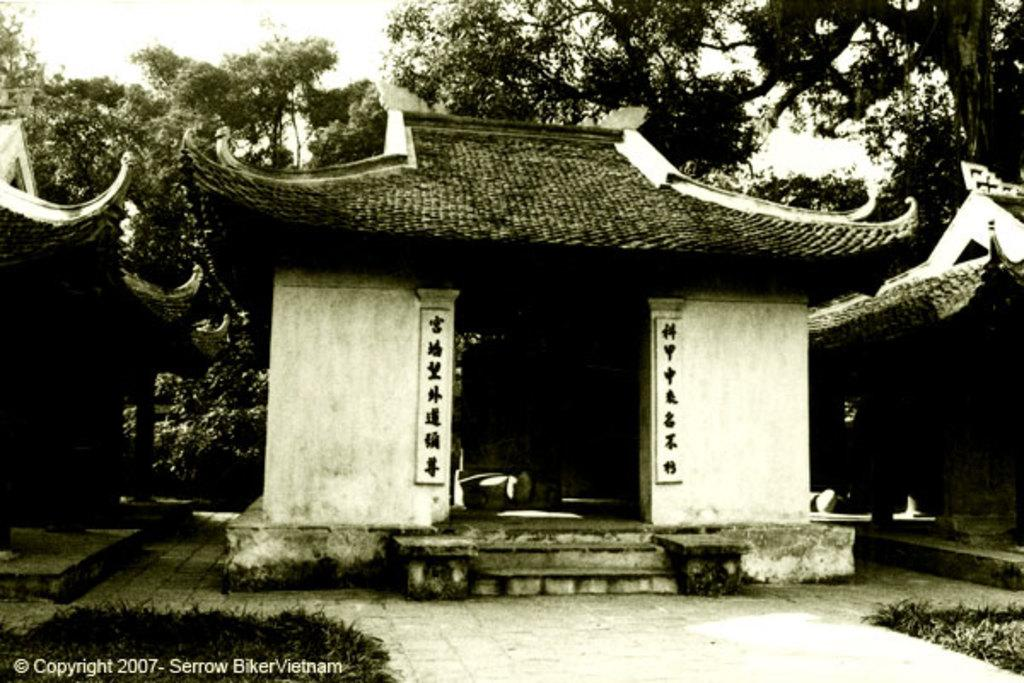What type of structures can be seen in the image? There are houses in the image. What type of vegetation is present in the image? There are trees and grass in the image. Can you describe any text that is visible in the image? There is text written at the bottom of the image. What type of protest is taking place in the image? There is no protest present in the image; it features houses, trees, grass, and text. Can you tell me how many uncles are visible in the image? There are no uncles present in the image. 